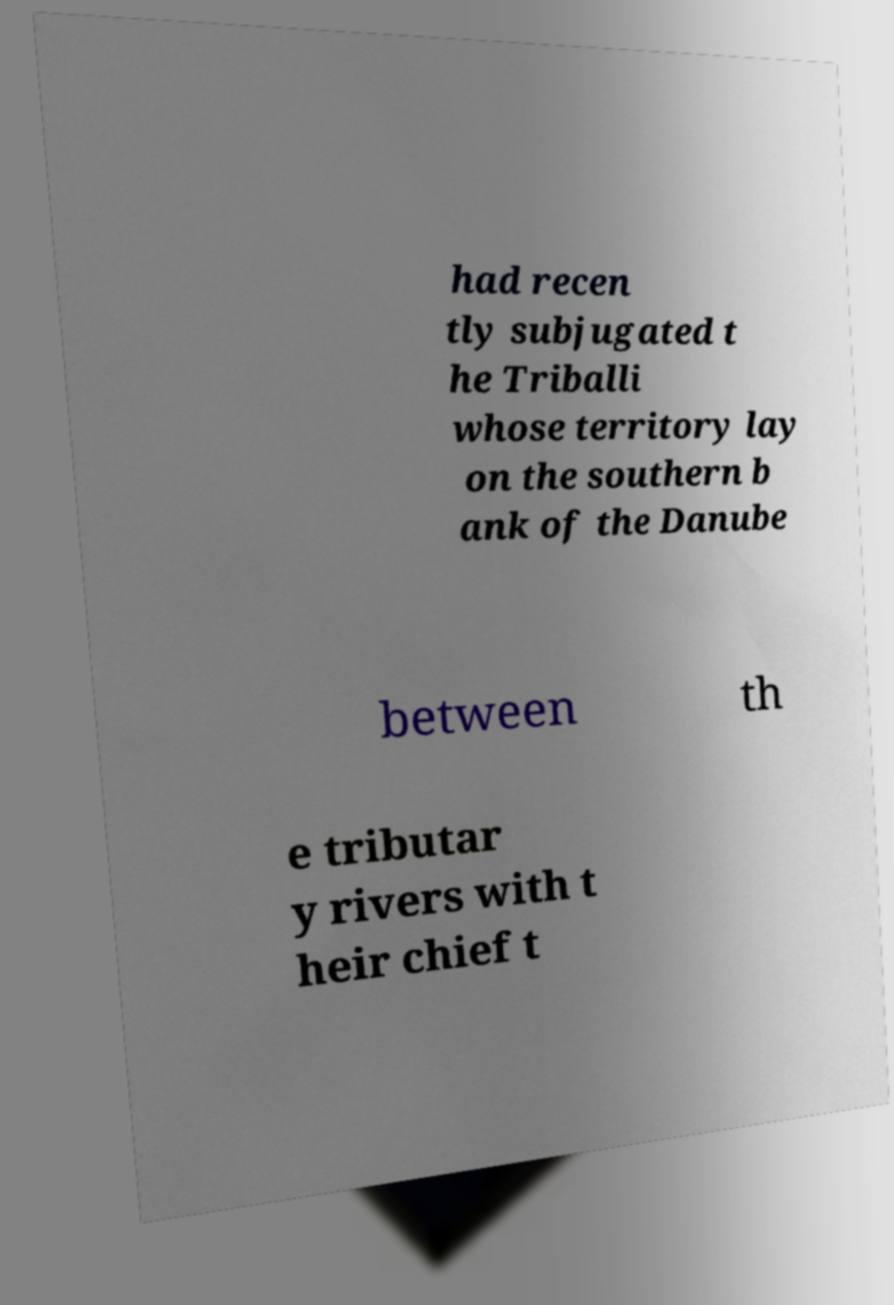Please identify and transcribe the text found in this image. had recen tly subjugated t he Triballi whose territory lay on the southern b ank of the Danube between th e tributar y rivers with t heir chief t 